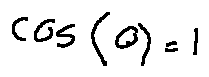Convert formula to latex. <formula><loc_0><loc_0><loc_500><loc_500>\cos ( 0 ) = 1</formula> 